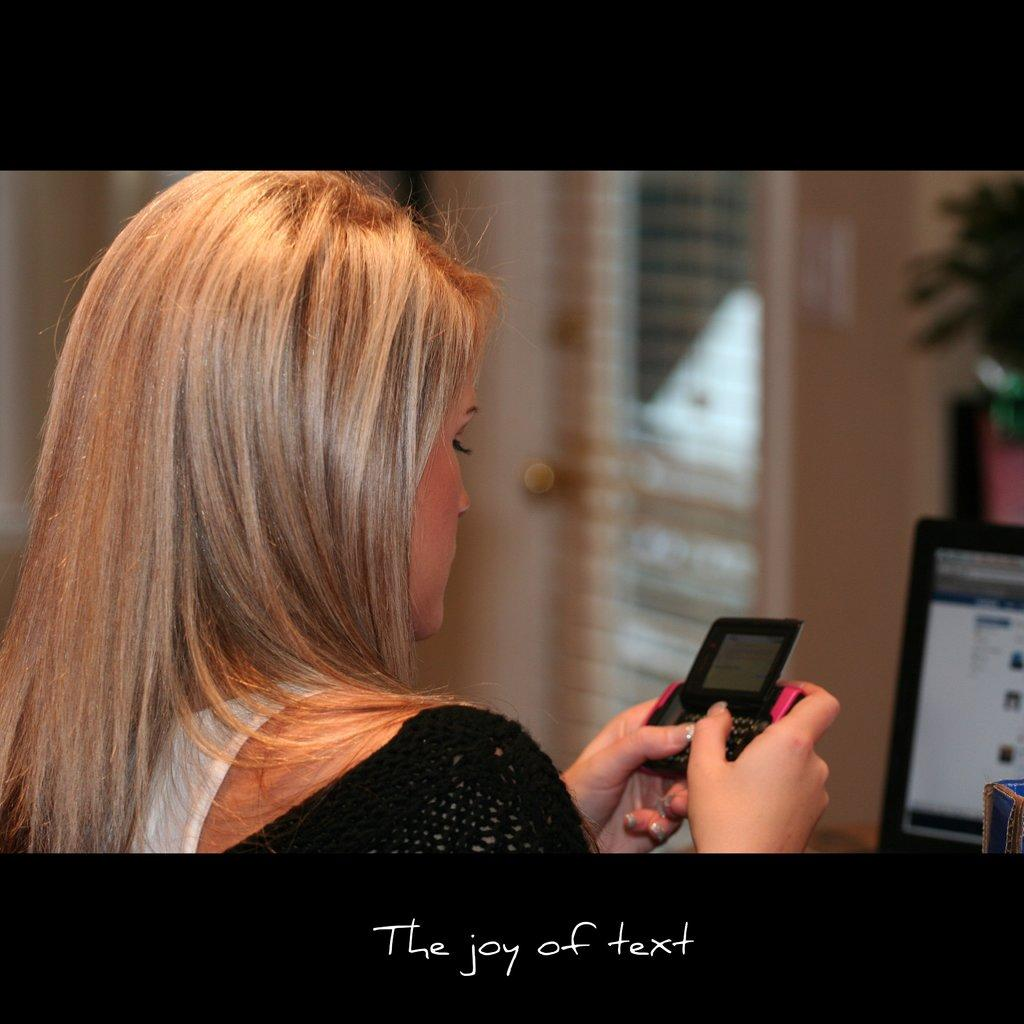Who is present in the image? There is a woman in the image. What is the woman doing in the image? The woman is using a mobile phone. What electronic device is visible on the right side of the image? There is a laptop visible on the right side of the image. How many cows are present in the image? There are no cows present in the image. What type of organization is depicted in the image? There is no organization depicted in the image; it features a woman using a mobile phone and a laptop. 